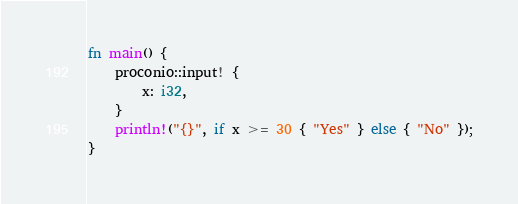<code> <loc_0><loc_0><loc_500><loc_500><_Rust_>fn main() {
    proconio::input! {
        x: i32,
    }
    println!("{}", if x >= 30 { "Yes" } else { "No" });
}
</code> 